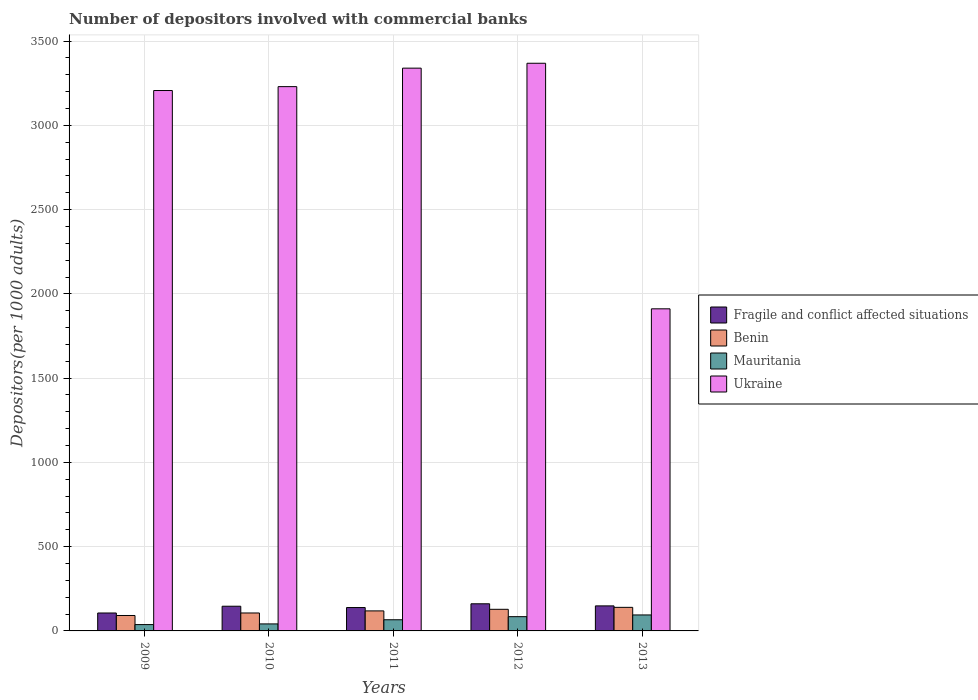How many different coloured bars are there?
Your answer should be very brief. 4. Are the number of bars on each tick of the X-axis equal?
Provide a short and direct response. Yes. How many bars are there on the 1st tick from the right?
Your answer should be compact. 4. What is the number of depositors involved with commercial banks in Ukraine in 2011?
Offer a terse response. 3339.41. Across all years, what is the maximum number of depositors involved with commercial banks in Mauritania?
Keep it short and to the point. 94.78. Across all years, what is the minimum number of depositors involved with commercial banks in Mauritania?
Ensure brevity in your answer.  37.6. In which year was the number of depositors involved with commercial banks in Ukraine minimum?
Your answer should be compact. 2013. What is the total number of depositors involved with commercial banks in Mauritania in the graph?
Offer a very short reply. 324.76. What is the difference between the number of depositors involved with commercial banks in Ukraine in 2011 and that in 2013?
Your response must be concise. 1428.17. What is the difference between the number of depositors involved with commercial banks in Benin in 2009 and the number of depositors involved with commercial banks in Fragile and conflict affected situations in 2013?
Your answer should be compact. -56.99. What is the average number of depositors involved with commercial banks in Mauritania per year?
Provide a succinct answer. 64.95. In the year 2010, what is the difference between the number of depositors involved with commercial banks in Benin and number of depositors involved with commercial banks in Fragile and conflict affected situations?
Provide a short and direct response. -40.01. In how many years, is the number of depositors involved with commercial banks in Fragile and conflict affected situations greater than 1300?
Provide a succinct answer. 0. What is the ratio of the number of depositors involved with commercial banks in Ukraine in 2009 to that in 2010?
Provide a short and direct response. 0.99. Is the difference between the number of depositors involved with commercial banks in Benin in 2011 and 2012 greater than the difference between the number of depositors involved with commercial banks in Fragile and conflict affected situations in 2011 and 2012?
Offer a terse response. Yes. What is the difference between the highest and the second highest number of depositors involved with commercial banks in Mauritania?
Ensure brevity in your answer.  10.17. What is the difference between the highest and the lowest number of depositors involved with commercial banks in Mauritania?
Keep it short and to the point. 57.18. In how many years, is the number of depositors involved with commercial banks in Fragile and conflict affected situations greater than the average number of depositors involved with commercial banks in Fragile and conflict affected situations taken over all years?
Provide a short and direct response. 3. Is the sum of the number of depositors involved with commercial banks in Benin in 2010 and 2013 greater than the maximum number of depositors involved with commercial banks in Fragile and conflict affected situations across all years?
Ensure brevity in your answer.  Yes. Is it the case that in every year, the sum of the number of depositors involved with commercial banks in Ukraine and number of depositors involved with commercial banks in Benin is greater than the sum of number of depositors involved with commercial banks in Fragile and conflict affected situations and number of depositors involved with commercial banks in Mauritania?
Offer a very short reply. Yes. What does the 3rd bar from the left in 2010 represents?
Your answer should be compact. Mauritania. What does the 1st bar from the right in 2009 represents?
Make the answer very short. Ukraine. Is it the case that in every year, the sum of the number of depositors involved with commercial banks in Fragile and conflict affected situations and number of depositors involved with commercial banks in Mauritania is greater than the number of depositors involved with commercial banks in Benin?
Provide a short and direct response. Yes. Does the graph contain any zero values?
Offer a very short reply. No. Does the graph contain grids?
Your response must be concise. Yes. Where does the legend appear in the graph?
Offer a very short reply. Center right. What is the title of the graph?
Offer a terse response. Number of depositors involved with commercial banks. What is the label or title of the X-axis?
Give a very brief answer. Years. What is the label or title of the Y-axis?
Keep it short and to the point. Depositors(per 1000 adults). What is the Depositors(per 1000 adults) of Fragile and conflict affected situations in 2009?
Give a very brief answer. 106.41. What is the Depositors(per 1000 adults) of Benin in 2009?
Offer a very short reply. 91.54. What is the Depositors(per 1000 adults) of Mauritania in 2009?
Offer a very short reply. 37.6. What is the Depositors(per 1000 adults) in Ukraine in 2009?
Offer a very short reply. 3206.64. What is the Depositors(per 1000 adults) in Fragile and conflict affected situations in 2010?
Provide a succinct answer. 146.5. What is the Depositors(per 1000 adults) of Benin in 2010?
Your response must be concise. 106.49. What is the Depositors(per 1000 adults) in Mauritania in 2010?
Ensure brevity in your answer.  41.54. What is the Depositors(per 1000 adults) in Ukraine in 2010?
Offer a very short reply. 3229.69. What is the Depositors(per 1000 adults) of Fragile and conflict affected situations in 2011?
Offer a very short reply. 138.74. What is the Depositors(per 1000 adults) of Benin in 2011?
Your answer should be compact. 118.8. What is the Depositors(per 1000 adults) of Mauritania in 2011?
Your response must be concise. 66.23. What is the Depositors(per 1000 adults) of Ukraine in 2011?
Offer a terse response. 3339.41. What is the Depositors(per 1000 adults) in Fragile and conflict affected situations in 2012?
Make the answer very short. 161.02. What is the Depositors(per 1000 adults) of Benin in 2012?
Offer a terse response. 128.27. What is the Depositors(per 1000 adults) of Mauritania in 2012?
Offer a very short reply. 84.61. What is the Depositors(per 1000 adults) of Ukraine in 2012?
Your answer should be compact. 3368.39. What is the Depositors(per 1000 adults) of Fragile and conflict affected situations in 2013?
Offer a terse response. 148.53. What is the Depositors(per 1000 adults) in Benin in 2013?
Offer a terse response. 139.82. What is the Depositors(per 1000 adults) in Mauritania in 2013?
Give a very brief answer. 94.78. What is the Depositors(per 1000 adults) of Ukraine in 2013?
Your answer should be very brief. 1911.24. Across all years, what is the maximum Depositors(per 1000 adults) in Fragile and conflict affected situations?
Give a very brief answer. 161.02. Across all years, what is the maximum Depositors(per 1000 adults) of Benin?
Give a very brief answer. 139.82. Across all years, what is the maximum Depositors(per 1000 adults) of Mauritania?
Offer a very short reply. 94.78. Across all years, what is the maximum Depositors(per 1000 adults) of Ukraine?
Ensure brevity in your answer.  3368.39. Across all years, what is the minimum Depositors(per 1000 adults) in Fragile and conflict affected situations?
Offer a terse response. 106.41. Across all years, what is the minimum Depositors(per 1000 adults) of Benin?
Your answer should be very brief. 91.54. Across all years, what is the minimum Depositors(per 1000 adults) in Mauritania?
Your response must be concise. 37.6. Across all years, what is the minimum Depositors(per 1000 adults) of Ukraine?
Offer a very short reply. 1911.24. What is the total Depositors(per 1000 adults) in Fragile and conflict affected situations in the graph?
Provide a succinct answer. 701.2. What is the total Depositors(per 1000 adults) of Benin in the graph?
Your answer should be very brief. 584.92. What is the total Depositors(per 1000 adults) in Mauritania in the graph?
Make the answer very short. 324.76. What is the total Depositors(per 1000 adults) of Ukraine in the graph?
Provide a succinct answer. 1.51e+04. What is the difference between the Depositors(per 1000 adults) in Fragile and conflict affected situations in 2009 and that in 2010?
Keep it short and to the point. -40.09. What is the difference between the Depositors(per 1000 adults) in Benin in 2009 and that in 2010?
Give a very brief answer. -14.95. What is the difference between the Depositors(per 1000 adults) in Mauritania in 2009 and that in 2010?
Offer a terse response. -3.93. What is the difference between the Depositors(per 1000 adults) in Ukraine in 2009 and that in 2010?
Give a very brief answer. -23.06. What is the difference between the Depositors(per 1000 adults) of Fragile and conflict affected situations in 2009 and that in 2011?
Give a very brief answer. -32.34. What is the difference between the Depositors(per 1000 adults) of Benin in 2009 and that in 2011?
Your response must be concise. -27.26. What is the difference between the Depositors(per 1000 adults) of Mauritania in 2009 and that in 2011?
Make the answer very short. -28.63. What is the difference between the Depositors(per 1000 adults) of Ukraine in 2009 and that in 2011?
Your answer should be compact. -132.77. What is the difference between the Depositors(per 1000 adults) in Fragile and conflict affected situations in 2009 and that in 2012?
Offer a terse response. -54.61. What is the difference between the Depositors(per 1000 adults) of Benin in 2009 and that in 2012?
Ensure brevity in your answer.  -36.73. What is the difference between the Depositors(per 1000 adults) of Mauritania in 2009 and that in 2012?
Your answer should be very brief. -47.01. What is the difference between the Depositors(per 1000 adults) of Ukraine in 2009 and that in 2012?
Your answer should be compact. -161.75. What is the difference between the Depositors(per 1000 adults) in Fragile and conflict affected situations in 2009 and that in 2013?
Your answer should be very brief. -42.13. What is the difference between the Depositors(per 1000 adults) of Benin in 2009 and that in 2013?
Your response must be concise. -48.27. What is the difference between the Depositors(per 1000 adults) in Mauritania in 2009 and that in 2013?
Ensure brevity in your answer.  -57.18. What is the difference between the Depositors(per 1000 adults) of Ukraine in 2009 and that in 2013?
Your answer should be compact. 1295.4. What is the difference between the Depositors(per 1000 adults) of Fragile and conflict affected situations in 2010 and that in 2011?
Give a very brief answer. 7.75. What is the difference between the Depositors(per 1000 adults) in Benin in 2010 and that in 2011?
Your answer should be compact. -12.31. What is the difference between the Depositors(per 1000 adults) of Mauritania in 2010 and that in 2011?
Offer a terse response. -24.69. What is the difference between the Depositors(per 1000 adults) in Ukraine in 2010 and that in 2011?
Offer a very short reply. -109.71. What is the difference between the Depositors(per 1000 adults) of Fragile and conflict affected situations in 2010 and that in 2012?
Ensure brevity in your answer.  -14.52. What is the difference between the Depositors(per 1000 adults) of Benin in 2010 and that in 2012?
Give a very brief answer. -21.78. What is the difference between the Depositors(per 1000 adults) of Mauritania in 2010 and that in 2012?
Your response must be concise. -43.07. What is the difference between the Depositors(per 1000 adults) in Ukraine in 2010 and that in 2012?
Provide a short and direct response. -138.7. What is the difference between the Depositors(per 1000 adults) of Fragile and conflict affected situations in 2010 and that in 2013?
Keep it short and to the point. -2.04. What is the difference between the Depositors(per 1000 adults) of Benin in 2010 and that in 2013?
Offer a very short reply. -33.33. What is the difference between the Depositors(per 1000 adults) in Mauritania in 2010 and that in 2013?
Make the answer very short. -53.24. What is the difference between the Depositors(per 1000 adults) of Ukraine in 2010 and that in 2013?
Your answer should be compact. 1318.46. What is the difference between the Depositors(per 1000 adults) in Fragile and conflict affected situations in 2011 and that in 2012?
Provide a short and direct response. -22.28. What is the difference between the Depositors(per 1000 adults) in Benin in 2011 and that in 2012?
Offer a very short reply. -9.46. What is the difference between the Depositors(per 1000 adults) of Mauritania in 2011 and that in 2012?
Offer a very short reply. -18.38. What is the difference between the Depositors(per 1000 adults) in Ukraine in 2011 and that in 2012?
Keep it short and to the point. -28.98. What is the difference between the Depositors(per 1000 adults) of Fragile and conflict affected situations in 2011 and that in 2013?
Your response must be concise. -9.79. What is the difference between the Depositors(per 1000 adults) of Benin in 2011 and that in 2013?
Your answer should be compact. -21.01. What is the difference between the Depositors(per 1000 adults) of Mauritania in 2011 and that in 2013?
Your answer should be compact. -28.55. What is the difference between the Depositors(per 1000 adults) of Ukraine in 2011 and that in 2013?
Your answer should be very brief. 1428.17. What is the difference between the Depositors(per 1000 adults) in Fragile and conflict affected situations in 2012 and that in 2013?
Provide a succinct answer. 12.49. What is the difference between the Depositors(per 1000 adults) of Benin in 2012 and that in 2013?
Keep it short and to the point. -11.55. What is the difference between the Depositors(per 1000 adults) of Mauritania in 2012 and that in 2013?
Offer a terse response. -10.17. What is the difference between the Depositors(per 1000 adults) in Ukraine in 2012 and that in 2013?
Keep it short and to the point. 1457.15. What is the difference between the Depositors(per 1000 adults) in Fragile and conflict affected situations in 2009 and the Depositors(per 1000 adults) in Benin in 2010?
Your response must be concise. -0.08. What is the difference between the Depositors(per 1000 adults) of Fragile and conflict affected situations in 2009 and the Depositors(per 1000 adults) of Mauritania in 2010?
Provide a succinct answer. 64.87. What is the difference between the Depositors(per 1000 adults) in Fragile and conflict affected situations in 2009 and the Depositors(per 1000 adults) in Ukraine in 2010?
Your answer should be compact. -3123.29. What is the difference between the Depositors(per 1000 adults) in Benin in 2009 and the Depositors(per 1000 adults) in Mauritania in 2010?
Your answer should be very brief. 50.01. What is the difference between the Depositors(per 1000 adults) of Benin in 2009 and the Depositors(per 1000 adults) of Ukraine in 2010?
Your answer should be compact. -3138.15. What is the difference between the Depositors(per 1000 adults) in Mauritania in 2009 and the Depositors(per 1000 adults) in Ukraine in 2010?
Your answer should be very brief. -3192.09. What is the difference between the Depositors(per 1000 adults) in Fragile and conflict affected situations in 2009 and the Depositors(per 1000 adults) in Benin in 2011?
Your answer should be compact. -12.4. What is the difference between the Depositors(per 1000 adults) in Fragile and conflict affected situations in 2009 and the Depositors(per 1000 adults) in Mauritania in 2011?
Make the answer very short. 40.18. What is the difference between the Depositors(per 1000 adults) of Fragile and conflict affected situations in 2009 and the Depositors(per 1000 adults) of Ukraine in 2011?
Provide a short and direct response. -3233. What is the difference between the Depositors(per 1000 adults) of Benin in 2009 and the Depositors(per 1000 adults) of Mauritania in 2011?
Provide a short and direct response. 25.31. What is the difference between the Depositors(per 1000 adults) of Benin in 2009 and the Depositors(per 1000 adults) of Ukraine in 2011?
Keep it short and to the point. -3247.86. What is the difference between the Depositors(per 1000 adults) of Mauritania in 2009 and the Depositors(per 1000 adults) of Ukraine in 2011?
Your answer should be very brief. -3301.8. What is the difference between the Depositors(per 1000 adults) of Fragile and conflict affected situations in 2009 and the Depositors(per 1000 adults) of Benin in 2012?
Provide a short and direct response. -21.86. What is the difference between the Depositors(per 1000 adults) in Fragile and conflict affected situations in 2009 and the Depositors(per 1000 adults) in Mauritania in 2012?
Provide a succinct answer. 21.79. What is the difference between the Depositors(per 1000 adults) in Fragile and conflict affected situations in 2009 and the Depositors(per 1000 adults) in Ukraine in 2012?
Your answer should be very brief. -3261.98. What is the difference between the Depositors(per 1000 adults) of Benin in 2009 and the Depositors(per 1000 adults) of Mauritania in 2012?
Your answer should be very brief. 6.93. What is the difference between the Depositors(per 1000 adults) in Benin in 2009 and the Depositors(per 1000 adults) in Ukraine in 2012?
Offer a terse response. -3276.85. What is the difference between the Depositors(per 1000 adults) of Mauritania in 2009 and the Depositors(per 1000 adults) of Ukraine in 2012?
Your response must be concise. -3330.79. What is the difference between the Depositors(per 1000 adults) of Fragile and conflict affected situations in 2009 and the Depositors(per 1000 adults) of Benin in 2013?
Provide a succinct answer. -33.41. What is the difference between the Depositors(per 1000 adults) of Fragile and conflict affected situations in 2009 and the Depositors(per 1000 adults) of Mauritania in 2013?
Your answer should be very brief. 11.63. What is the difference between the Depositors(per 1000 adults) of Fragile and conflict affected situations in 2009 and the Depositors(per 1000 adults) of Ukraine in 2013?
Your answer should be compact. -1804.83. What is the difference between the Depositors(per 1000 adults) of Benin in 2009 and the Depositors(per 1000 adults) of Mauritania in 2013?
Make the answer very short. -3.24. What is the difference between the Depositors(per 1000 adults) in Benin in 2009 and the Depositors(per 1000 adults) in Ukraine in 2013?
Your response must be concise. -1819.69. What is the difference between the Depositors(per 1000 adults) in Mauritania in 2009 and the Depositors(per 1000 adults) in Ukraine in 2013?
Ensure brevity in your answer.  -1873.63. What is the difference between the Depositors(per 1000 adults) in Fragile and conflict affected situations in 2010 and the Depositors(per 1000 adults) in Benin in 2011?
Your answer should be very brief. 27.69. What is the difference between the Depositors(per 1000 adults) of Fragile and conflict affected situations in 2010 and the Depositors(per 1000 adults) of Mauritania in 2011?
Your answer should be compact. 80.27. What is the difference between the Depositors(per 1000 adults) of Fragile and conflict affected situations in 2010 and the Depositors(per 1000 adults) of Ukraine in 2011?
Offer a very short reply. -3192.91. What is the difference between the Depositors(per 1000 adults) in Benin in 2010 and the Depositors(per 1000 adults) in Mauritania in 2011?
Offer a very short reply. 40.26. What is the difference between the Depositors(per 1000 adults) in Benin in 2010 and the Depositors(per 1000 adults) in Ukraine in 2011?
Ensure brevity in your answer.  -3232.92. What is the difference between the Depositors(per 1000 adults) in Mauritania in 2010 and the Depositors(per 1000 adults) in Ukraine in 2011?
Your answer should be very brief. -3297.87. What is the difference between the Depositors(per 1000 adults) in Fragile and conflict affected situations in 2010 and the Depositors(per 1000 adults) in Benin in 2012?
Make the answer very short. 18.23. What is the difference between the Depositors(per 1000 adults) of Fragile and conflict affected situations in 2010 and the Depositors(per 1000 adults) of Mauritania in 2012?
Offer a terse response. 61.88. What is the difference between the Depositors(per 1000 adults) of Fragile and conflict affected situations in 2010 and the Depositors(per 1000 adults) of Ukraine in 2012?
Your answer should be very brief. -3221.89. What is the difference between the Depositors(per 1000 adults) in Benin in 2010 and the Depositors(per 1000 adults) in Mauritania in 2012?
Offer a very short reply. 21.88. What is the difference between the Depositors(per 1000 adults) of Benin in 2010 and the Depositors(per 1000 adults) of Ukraine in 2012?
Give a very brief answer. -3261.9. What is the difference between the Depositors(per 1000 adults) in Mauritania in 2010 and the Depositors(per 1000 adults) in Ukraine in 2012?
Give a very brief answer. -3326.85. What is the difference between the Depositors(per 1000 adults) in Fragile and conflict affected situations in 2010 and the Depositors(per 1000 adults) in Benin in 2013?
Offer a terse response. 6.68. What is the difference between the Depositors(per 1000 adults) in Fragile and conflict affected situations in 2010 and the Depositors(per 1000 adults) in Mauritania in 2013?
Your response must be concise. 51.72. What is the difference between the Depositors(per 1000 adults) of Fragile and conflict affected situations in 2010 and the Depositors(per 1000 adults) of Ukraine in 2013?
Provide a succinct answer. -1764.74. What is the difference between the Depositors(per 1000 adults) in Benin in 2010 and the Depositors(per 1000 adults) in Mauritania in 2013?
Your answer should be compact. 11.71. What is the difference between the Depositors(per 1000 adults) of Benin in 2010 and the Depositors(per 1000 adults) of Ukraine in 2013?
Give a very brief answer. -1804.75. What is the difference between the Depositors(per 1000 adults) of Mauritania in 2010 and the Depositors(per 1000 adults) of Ukraine in 2013?
Provide a short and direct response. -1869.7. What is the difference between the Depositors(per 1000 adults) of Fragile and conflict affected situations in 2011 and the Depositors(per 1000 adults) of Benin in 2012?
Your response must be concise. 10.47. What is the difference between the Depositors(per 1000 adults) of Fragile and conflict affected situations in 2011 and the Depositors(per 1000 adults) of Mauritania in 2012?
Provide a short and direct response. 54.13. What is the difference between the Depositors(per 1000 adults) in Fragile and conflict affected situations in 2011 and the Depositors(per 1000 adults) in Ukraine in 2012?
Make the answer very short. -3229.65. What is the difference between the Depositors(per 1000 adults) in Benin in 2011 and the Depositors(per 1000 adults) in Mauritania in 2012?
Keep it short and to the point. 34.19. What is the difference between the Depositors(per 1000 adults) of Benin in 2011 and the Depositors(per 1000 adults) of Ukraine in 2012?
Your answer should be compact. -3249.58. What is the difference between the Depositors(per 1000 adults) in Mauritania in 2011 and the Depositors(per 1000 adults) in Ukraine in 2012?
Your answer should be compact. -3302.16. What is the difference between the Depositors(per 1000 adults) of Fragile and conflict affected situations in 2011 and the Depositors(per 1000 adults) of Benin in 2013?
Provide a succinct answer. -1.07. What is the difference between the Depositors(per 1000 adults) of Fragile and conflict affected situations in 2011 and the Depositors(per 1000 adults) of Mauritania in 2013?
Provide a short and direct response. 43.96. What is the difference between the Depositors(per 1000 adults) in Fragile and conflict affected situations in 2011 and the Depositors(per 1000 adults) in Ukraine in 2013?
Make the answer very short. -1772.49. What is the difference between the Depositors(per 1000 adults) of Benin in 2011 and the Depositors(per 1000 adults) of Mauritania in 2013?
Your answer should be very brief. 24.02. What is the difference between the Depositors(per 1000 adults) in Benin in 2011 and the Depositors(per 1000 adults) in Ukraine in 2013?
Your answer should be compact. -1792.43. What is the difference between the Depositors(per 1000 adults) in Mauritania in 2011 and the Depositors(per 1000 adults) in Ukraine in 2013?
Provide a succinct answer. -1845. What is the difference between the Depositors(per 1000 adults) in Fragile and conflict affected situations in 2012 and the Depositors(per 1000 adults) in Benin in 2013?
Keep it short and to the point. 21.21. What is the difference between the Depositors(per 1000 adults) of Fragile and conflict affected situations in 2012 and the Depositors(per 1000 adults) of Mauritania in 2013?
Provide a short and direct response. 66.24. What is the difference between the Depositors(per 1000 adults) in Fragile and conflict affected situations in 2012 and the Depositors(per 1000 adults) in Ukraine in 2013?
Provide a succinct answer. -1750.21. What is the difference between the Depositors(per 1000 adults) of Benin in 2012 and the Depositors(per 1000 adults) of Mauritania in 2013?
Keep it short and to the point. 33.49. What is the difference between the Depositors(per 1000 adults) of Benin in 2012 and the Depositors(per 1000 adults) of Ukraine in 2013?
Your answer should be very brief. -1782.97. What is the difference between the Depositors(per 1000 adults) of Mauritania in 2012 and the Depositors(per 1000 adults) of Ukraine in 2013?
Keep it short and to the point. -1826.62. What is the average Depositors(per 1000 adults) of Fragile and conflict affected situations per year?
Your response must be concise. 140.24. What is the average Depositors(per 1000 adults) of Benin per year?
Make the answer very short. 116.98. What is the average Depositors(per 1000 adults) of Mauritania per year?
Keep it short and to the point. 64.95. What is the average Depositors(per 1000 adults) in Ukraine per year?
Give a very brief answer. 3011.07. In the year 2009, what is the difference between the Depositors(per 1000 adults) of Fragile and conflict affected situations and Depositors(per 1000 adults) of Benin?
Provide a short and direct response. 14.86. In the year 2009, what is the difference between the Depositors(per 1000 adults) of Fragile and conflict affected situations and Depositors(per 1000 adults) of Mauritania?
Provide a short and direct response. 68.8. In the year 2009, what is the difference between the Depositors(per 1000 adults) in Fragile and conflict affected situations and Depositors(per 1000 adults) in Ukraine?
Provide a succinct answer. -3100.23. In the year 2009, what is the difference between the Depositors(per 1000 adults) in Benin and Depositors(per 1000 adults) in Mauritania?
Your response must be concise. 53.94. In the year 2009, what is the difference between the Depositors(per 1000 adults) in Benin and Depositors(per 1000 adults) in Ukraine?
Your response must be concise. -3115.09. In the year 2009, what is the difference between the Depositors(per 1000 adults) in Mauritania and Depositors(per 1000 adults) in Ukraine?
Provide a short and direct response. -3169.03. In the year 2010, what is the difference between the Depositors(per 1000 adults) of Fragile and conflict affected situations and Depositors(per 1000 adults) of Benin?
Provide a short and direct response. 40.01. In the year 2010, what is the difference between the Depositors(per 1000 adults) of Fragile and conflict affected situations and Depositors(per 1000 adults) of Mauritania?
Your answer should be compact. 104.96. In the year 2010, what is the difference between the Depositors(per 1000 adults) of Fragile and conflict affected situations and Depositors(per 1000 adults) of Ukraine?
Your response must be concise. -3083.2. In the year 2010, what is the difference between the Depositors(per 1000 adults) of Benin and Depositors(per 1000 adults) of Mauritania?
Keep it short and to the point. 64.95. In the year 2010, what is the difference between the Depositors(per 1000 adults) in Benin and Depositors(per 1000 adults) in Ukraine?
Make the answer very short. -3123.2. In the year 2010, what is the difference between the Depositors(per 1000 adults) of Mauritania and Depositors(per 1000 adults) of Ukraine?
Ensure brevity in your answer.  -3188.16. In the year 2011, what is the difference between the Depositors(per 1000 adults) in Fragile and conflict affected situations and Depositors(per 1000 adults) in Benin?
Your answer should be very brief. 19.94. In the year 2011, what is the difference between the Depositors(per 1000 adults) of Fragile and conflict affected situations and Depositors(per 1000 adults) of Mauritania?
Your answer should be compact. 72.51. In the year 2011, what is the difference between the Depositors(per 1000 adults) in Fragile and conflict affected situations and Depositors(per 1000 adults) in Ukraine?
Give a very brief answer. -3200.66. In the year 2011, what is the difference between the Depositors(per 1000 adults) in Benin and Depositors(per 1000 adults) in Mauritania?
Your answer should be compact. 52.57. In the year 2011, what is the difference between the Depositors(per 1000 adults) in Benin and Depositors(per 1000 adults) in Ukraine?
Offer a terse response. -3220.6. In the year 2011, what is the difference between the Depositors(per 1000 adults) in Mauritania and Depositors(per 1000 adults) in Ukraine?
Offer a very short reply. -3273.18. In the year 2012, what is the difference between the Depositors(per 1000 adults) of Fragile and conflict affected situations and Depositors(per 1000 adults) of Benin?
Your answer should be compact. 32.75. In the year 2012, what is the difference between the Depositors(per 1000 adults) of Fragile and conflict affected situations and Depositors(per 1000 adults) of Mauritania?
Offer a terse response. 76.41. In the year 2012, what is the difference between the Depositors(per 1000 adults) in Fragile and conflict affected situations and Depositors(per 1000 adults) in Ukraine?
Provide a succinct answer. -3207.37. In the year 2012, what is the difference between the Depositors(per 1000 adults) in Benin and Depositors(per 1000 adults) in Mauritania?
Your answer should be very brief. 43.66. In the year 2012, what is the difference between the Depositors(per 1000 adults) in Benin and Depositors(per 1000 adults) in Ukraine?
Your answer should be compact. -3240.12. In the year 2012, what is the difference between the Depositors(per 1000 adults) in Mauritania and Depositors(per 1000 adults) in Ukraine?
Offer a terse response. -3283.78. In the year 2013, what is the difference between the Depositors(per 1000 adults) of Fragile and conflict affected situations and Depositors(per 1000 adults) of Benin?
Your response must be concise. 8.72. In the year 2013, what is the difference between the Depositors(per 1000 adults) of Fragile and conflict affected situations and Depositors(per 1000 adults) of Mauritania?
Offer a very short reply. 53.75. In the year 2013, what is the difference between the Depositors(per 1000 adults) in Fragile and conflict affected situations and Depositors(per 1000 adults) in Ukraine?
Ensure brevity in your answer.  -1762.7. In the year 2013, what is the difference between the Depositors(per 1000 adults) in Benin and Depositors(per 1000 adults) in Mauritania?
Provide a short and direct response. 45.03. In the year 2013, what is the difference between the Depositors(per 1000 adults) in Benin and Depositors(per 1000 adults) in Ukraine?
Your answer should be compact. -1771.42. In the year 2013, what is the difference between the Depositors(per 1000 adults) of Mauritania and Depositors(per 1000 adults) of Ukraine?
Provide a succinct answer. -1816.45. What is the ratio of the Depositors(per 1000 adults) in Fragile and conflict affected situations in 2009 to that in 2010?
Make the answer very short. 0.73. What is the ratio of the Depositors(per 1000 adults) in Benin in 2009 to that in 2010?
Provide a succinct answer. 0.86. What is the ratio of the Depositors(per 1000 adults) in Mauritania in 2009 to that in 2010?
Provide a succinct answer. 0.91. What is the ratio of the Depositors(per 1000 adults) in Fragile and conflict affected situations in 2009 to that in 2011?
Provide a succinct answer. 0.77. What is the ratio of the Depositors(per 1000 adults) in Benin in 2009 to that in 2011?
Make the answer very short. 0.77. What is the ratio of the Depositors(per 1000 adults) of Mauritania in 2009 to that in 2011?
Offer a terse response. 0.57. What is the ratio of the Depositors(per 1000 adults) in Ukraine in 2009 to that in 2011?
Offer a very short reply. 0.96. What is the ratio of the Depositors(per 1000 adults) of Fragile and conflict affected situations in 2009 to that in 2012?
Offer a very short reply. 0.66. What is the ratio of the Depositors(per 1000 adults) in Benin in 2009 to that in 2012?
Ensure brevity in your answer.  0.71. What is the ratio of the Depositors(per 1000 adults) of Mauritania in 2009 to that in 2012?
Keep it short and to the point. 0.44. What is the ratio of the Depositors(per 1000 adults) in Ukraine in 2009 to that in 2012?
Offer a terse response. 0.95. What is the ratio of the Depositors(per 1000 adults) of Fragile and conflict affected situations in 2009 to that in 2013?
Make the answer very short. 0.72. What is the ratio of the Depositors(per 1000 adults) of Benin in 2009 to that in 2013?
Keep it short and to the point. 0.65. What is the ratio of the Depositors(per 1000 adults) in Mauritania in 2009 to that in 2013?
Keep it short and to the point. 0.4. What is the ratio of the Depositors(per 1000 adults) in Ukraine in 2009 to that in 2013?
Give a very brief answer. 1.68. What is the ratio of the Depositors(per 1000 adults) in Fragile and conflict affected situations in 2010 to that in 2011?
Give a very brief answer. 1.06. What is the ratio of the Depositors(per 1000 adults) in Benin in 2010 to that in 2011?
Give a very brief answer. 0.9. What is the ratio of the Depositors(per 1000 adults) of Mauritania in 2010 to that in 2011?
Your answer should be very brief. 0.63. What is the ratio of the Depositors(per 1000 adults) in Ukraine in 2010 to that in 2011?
Offer a very short reply. 0.97. What is the ratio of the Depositors(per 1000 adults) in Fragile and conflict affected situations in 2010 to that in 2012?
Provide a succinct answer. 0.91. What is the ratio of the Depositors(per 1000 adults) in Benin in 2010 to that in 2012?
Offer a terse response. 0.83. What is the ratio of the Depositors(per 1000 adults) of Mauritania in 2010 to that in 2012?
Keep it short and to the point. 0.49. What is the ratio of the Depositors(per 1000 adults) in Ukraine in 2010 to that in 2012?
Make the answer very short. 0.96. What is the ratio of the Depositors(per 1000 adults) of Fragile and conflict affected situations in 2010 to that in 2013?
Ensure brevity in your answer.  0.99. What is the ratio of the Depositors(per 1000 adults) in Benin in 2010 to that in 2013?
Provide a short and direct response. 0.76. What is the ratio of the Depositors(per 1000 adults) of Mauritania in 2010 to that in 2013?
Offer a terse response. 0.44. What is the ratio of the Depositors(per 1000 adults) in Ukraine in 2010 to that in 2013?
Offer a terse response. 1.69. What is the ratio of the Depositors(per 1000 adults) in Fragile and conflict affected situations in 2011 to that in 2012?
Your response must be concise. 0.86. What is the ratio of the Depositors(per 1000 adults) of Benin in 2011 to that in 2012?
Ensure brevity in your answer.  0.93. What is the ratio of the Depositors(per 1000 adults) in Mauritania in 2011 to that in 2012?
Your answer should be compact. 0.78. What is the ratio of the Depositors(per 1000 adults) of Fragile and conflict affected situations in 2011 to that in 2013?
Your answer should be compact. 0.93. What is the ratio of the Depositors(per 1000 adults) of Benin in 2011 to that in 2013?
Give a very brief answer. 0.85. What is the ratio of the Depositors(per 1000 adults) of Mauritania in 2011 to that in 2013?
Your answer should be very brief. 0.7. What is the ratio of the Depositors(per 1000 adults) in Ukraine in 2011 to that in 2013?
Your answer should be compact. 1.75. What is the ratio of the Depositors(per 1000 adults) of Fragile and conflict affected situations in 2012 to that in 2013?
Your response must be concise. 1.08. What is the ratio of the Depositors(per 1000 adults) in Benin in 2012 to that in 2013?
Offer a very short reply. 0.92. What is the ratio of the Depositors(per 1000 adults) in Mauritania in 2012 to that in 2013?
Your answer should be compact. 0.89. What is the ratio of the Depositors(per 1000 adults) in Ukraine in 2012 to that in 2013?
Give a very brief answer. 1.76. What is the difference between the highest and the second highest Depositors(per 1000 adults) in Fragile and conflict affected situations?
Your response must be concise. 12.49. What is the difference between the highest and the second highest Depositors(per 1000 adults) of Benin?
Ensure brevity in your answer.  11.55. What is the difference between the highest and the second highest Depositors(per 1000 adults) in Mauritania?
Your response must be concise. 10.17. What is the difference between the highest and the second highest Depositors(per 1000 adults) of Ukraine?
Your answer should be very brief. 28.98. What is the difference between the highest and the lowest Depositors(per 1000 adults) of Fragile and conflict affected situations?
Your response must be concise. 54.61. What is the difference between the highest and the lowest Depositors(per 1000 adults) of Benin?
Offer a terse response. 48.27. What is the difference between the highest and the lowest Depositors(per 1000 adults) of Mauritania?
Give a very brief answer. 57.18. What is the difference between the highest and the lowest Depositors(per 1000 adults) of Ukraine?
Ensure brevity in your answer.  1457.15. 